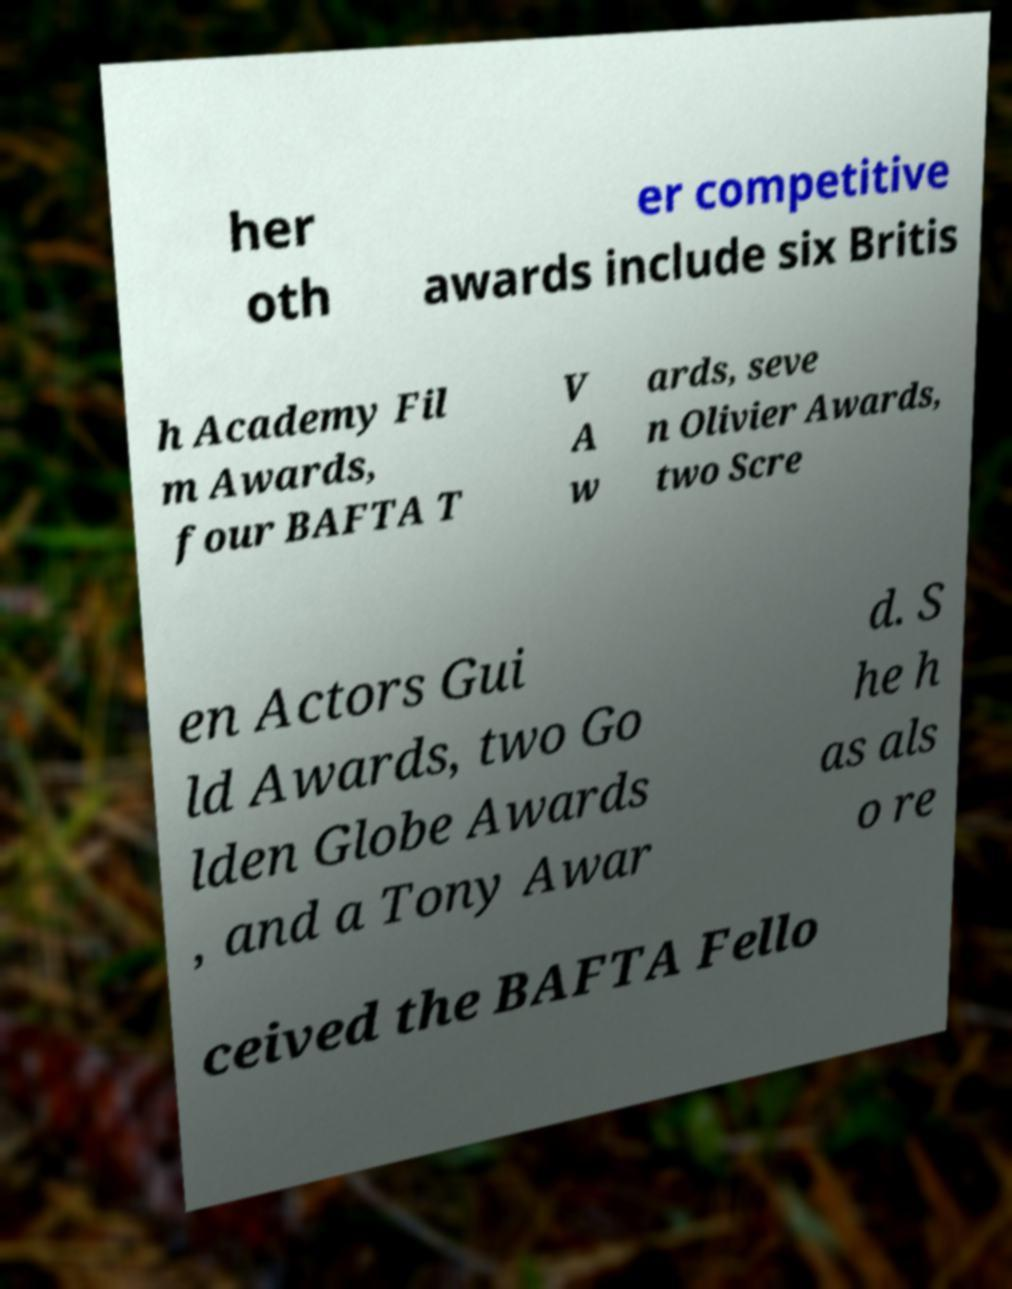What messages or text are displayed in this image? I need them in a readable, typed format. her oth er competitive awards include six Britis h Academy Fil m Awards, four BAFTA T V A w ards, seve n Olivier Awards, two Scre en Actors Gui ld Awards, two Go lden Globe Awards , and a Tony Awar d. S he h as als o re ceived the BAFTA Fello 